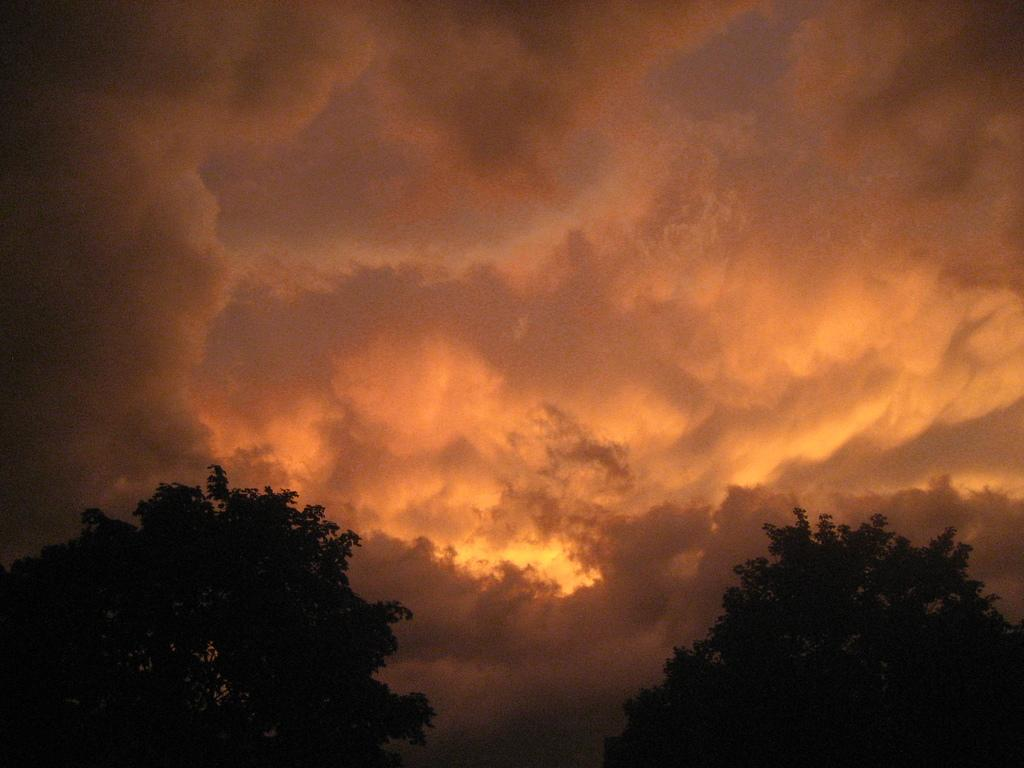What type of vegetation can be seen in the image? There are trees in the image. What part of the natural environment is visible in the image? The sky is visible in the image. What can be observed in the sky? Clouds are present in the sky. What type of disease is being treated in the image? There is no indication of a disease or treatment in the image; it features trees and a sky with clouds. What book is being read in the image? There is no book present in the image. 